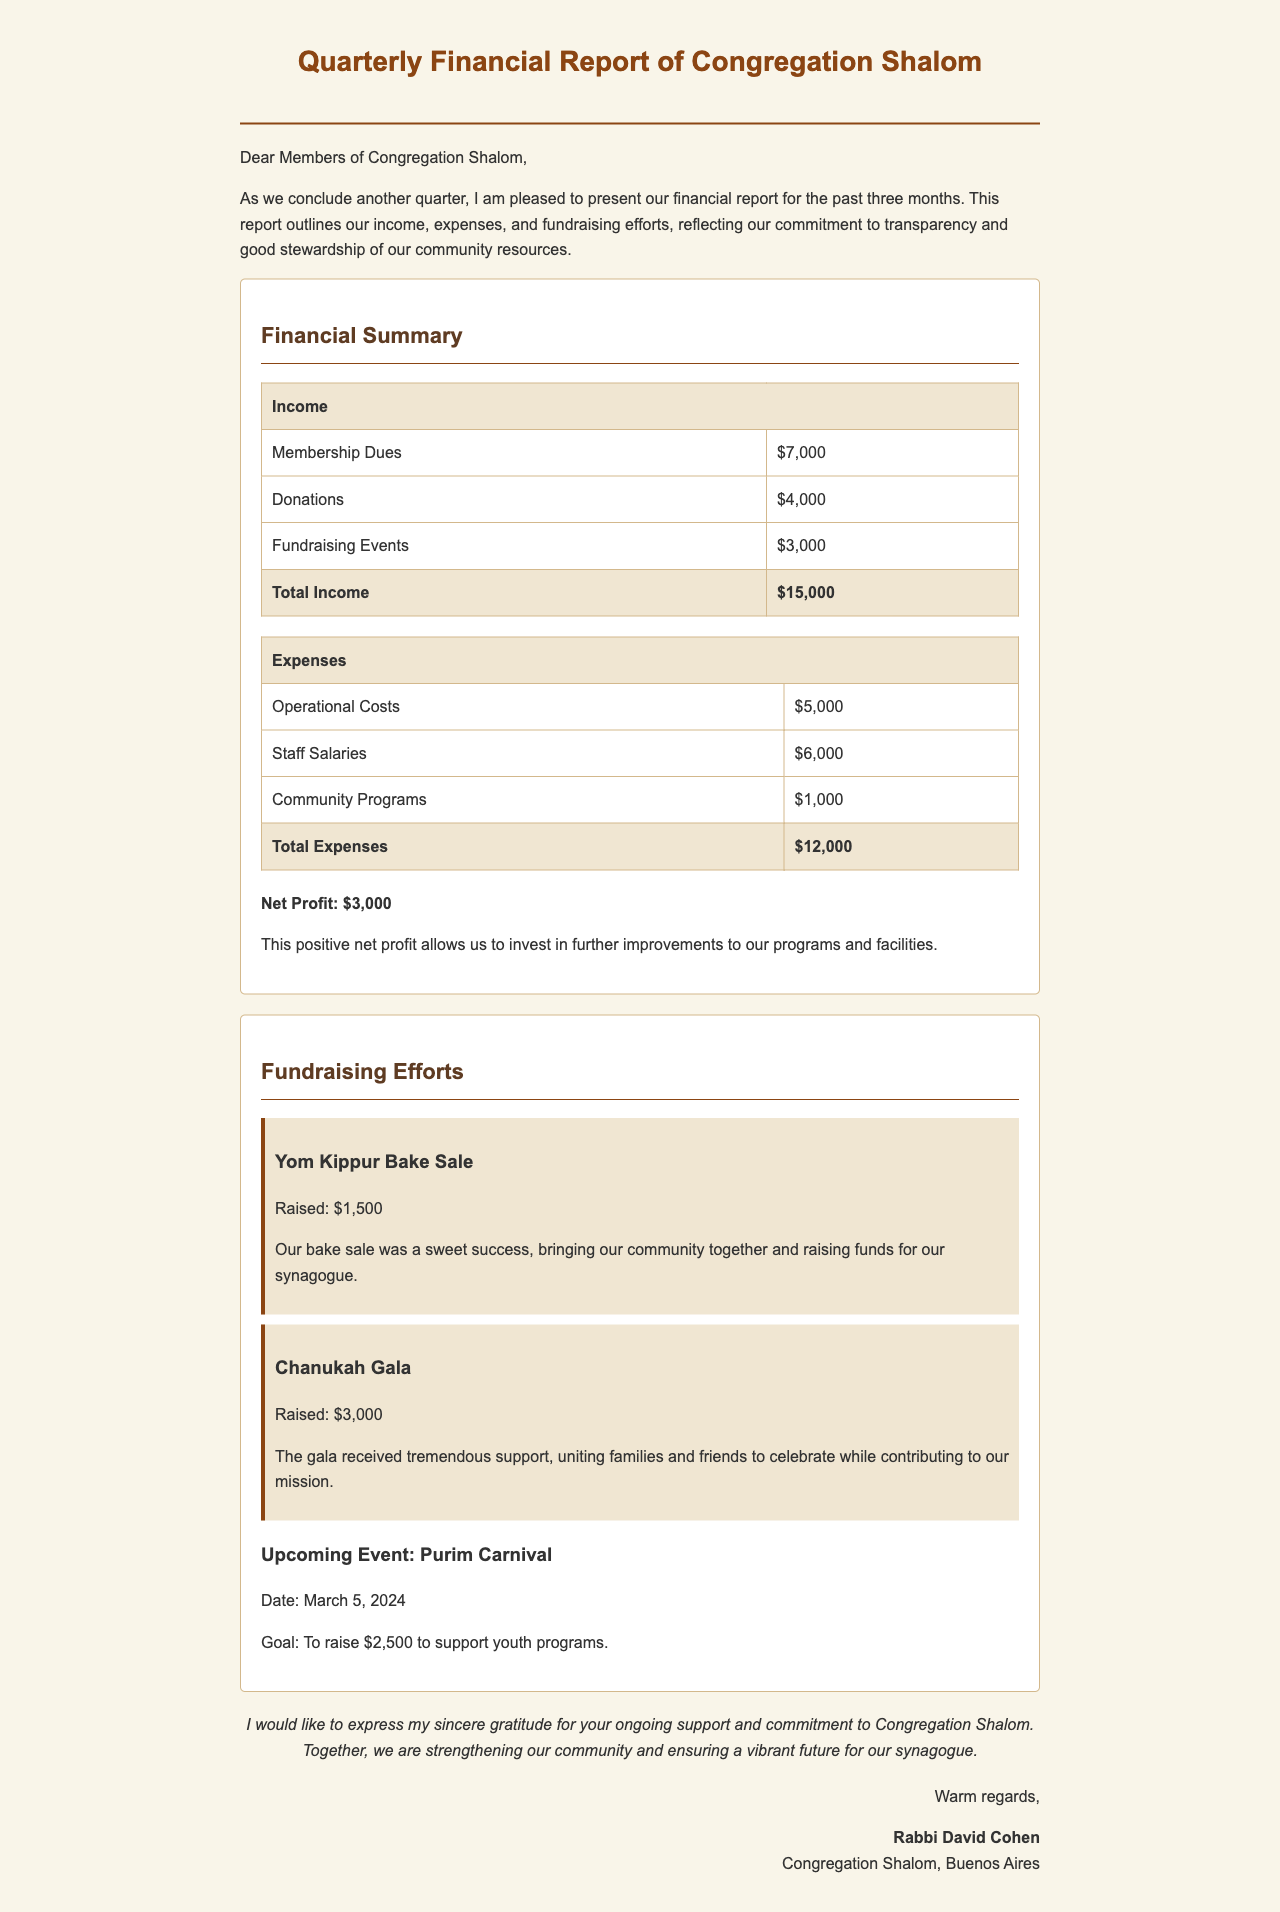what is the total income? The total income is presented in the financial summary, which includes membership dues, donations, and fundraising events.
Answer: $15,000 what is the amount raised from the Chanukah Gala? The amount raised from the Chanukah Gala is specifically mentioned in the fundraising efforts section.
Answer: $3,000 what is the date of the upcoming Purim Carnival? The date for the Purim Carnival is provided in the fundraising efforts section.
Answer: March 5, 2024 how much did the community programs cost? The cost of community programs is detailed in the expenses table of the financial summary.
Answer: $1,000 what is the net profit for the past quarter? The net profit is calculated by subtracting total expenses from total income in the financial summary.
Answer: $3,000 what are the operational costs? The operational costs are listed in the expenses section of the financial summary.
Answer: $5,000 how much was collected from the Yom Kippur Bake Sale? The amount collected from the Yom Kippur Bake Sale is stated in the fundraising efforts section of the report.
Answer: $1,500 who signed the report? The conclusion section includes information about who authored the report.
Answer: Rabbi David Cohen 